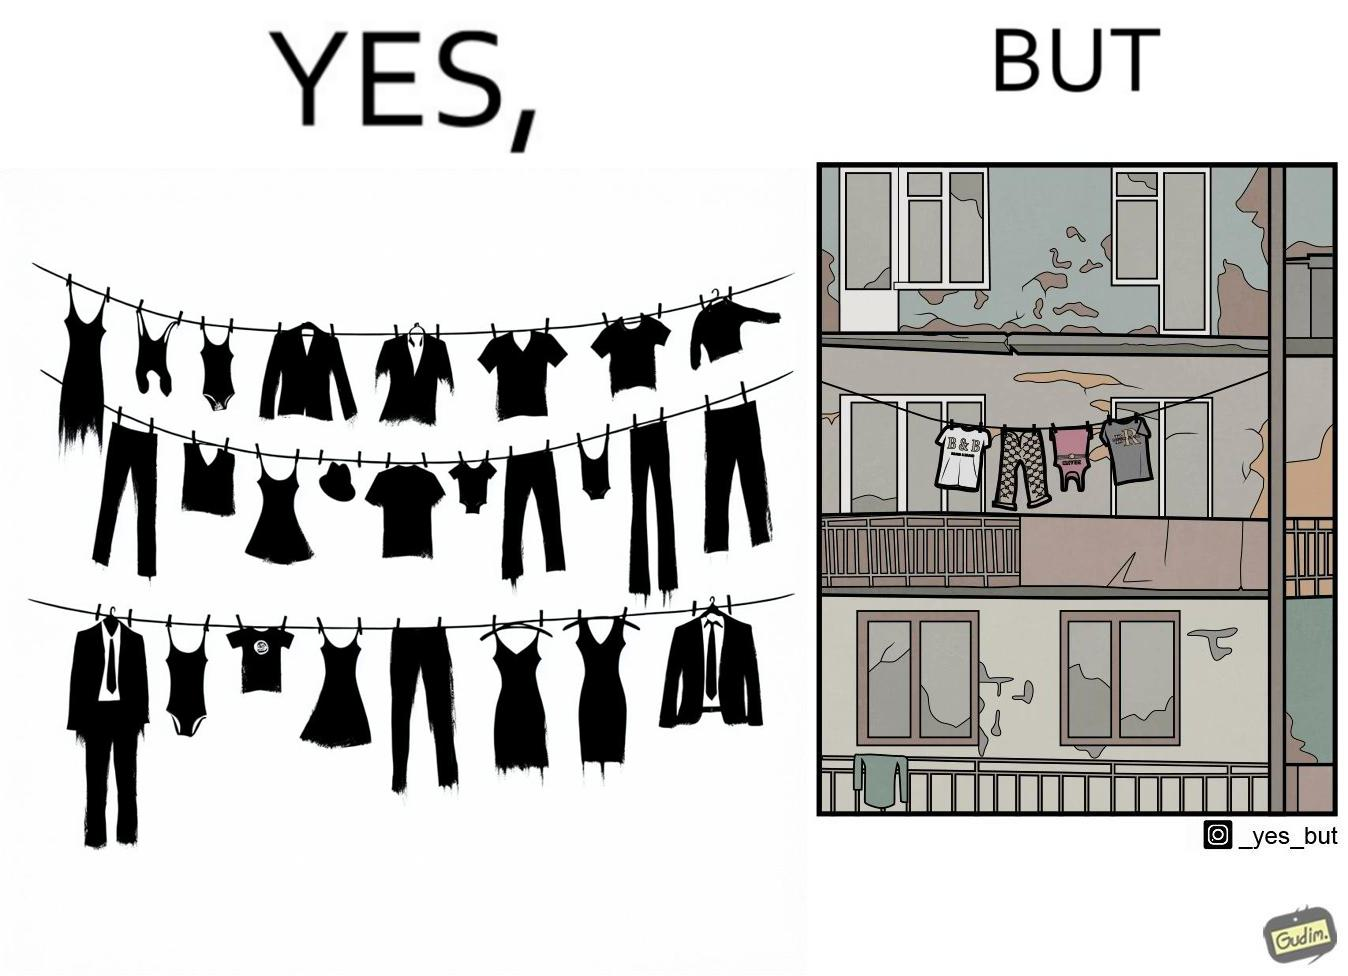Why is this image considered satirical? The image is ironic because although the clothes are of branded companies but they are hanging in very poor building. 